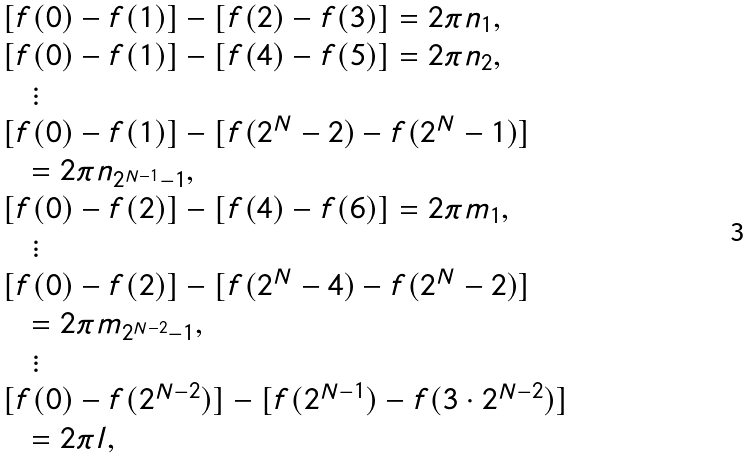Convert formula to latex. <formula><loc_0><loc_0><loc_500><loc_500>\begin{array} { l } { [ } f ( 0 ) - f ( 1 ) { ] } - { [ } f ( 2 ) - f ( 3 ) { ] } = 2 \pi n _ { 1 } , \\ { [ } f ( 0 ) - f ( 1 ) { ] } - { [ } f ( 4 ) - f ( 5 ) { ] } = 2 \pi n _ { 2 } , \\ \quad \vdots \\ { [ } f ( 0 ) - f ( 1 ) { ] } - { [ } f ( 2 ^ { N } - 2 ) - f ( 2 ^ { N } - 1 ) { ] } \\ \quad = 2 \pi n _ { 2 ^ { N - 1 } - 1 } , \\ { [ } f ( 0 ) - f ( 2 ) { ] } - { [ } f ( 4 ) - f ( 6 ) { ] } = 2 \pi m _ { 1 } , \\ \quad \vdots \\ { [ } f ( 0 ) - f ( 2 ) { ] } - { [ } f ( 2 ^ { N } - 4 ) - f ( 2 ^ { N } - 2 ) { ] } \\ \quad = 2 \pi m _ { 2 ^ { N - 2 } - 1 } , \\ \quad \vdots \\ { [ } f ( 0 ) - f ( 2 ^ { N - 2 } ) { ] } - { [ } f ( 2 ^ { N - 1 } ) - f ( 3 \cdot 2 ^ { N - 2 } ) { ] } \\ \quad = 2 \pi l , \end{array}</formula> 